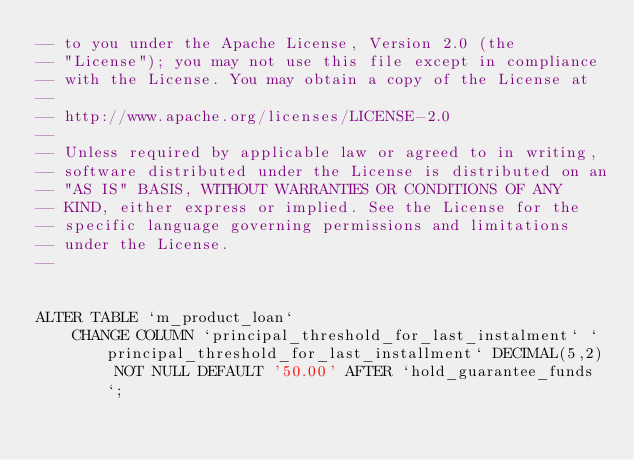<code> <loc_0><loc_0><loc_500><loc_500><_SQL_>-- to you under the Apache License, Version 2.0 (the
-- "License"); you may not use this file except in compliance
-- with the License. You may obtain a copy of the License at
--
-- http://www.apache.org/licenses/LICENSE-2.0
--
-- Unless required by applicable law or agreed to in writing,
-- software distributed under the License is distributed on an
-- "AS IS" BASIS, WITHOUT WARRANTIES OR CONDITIONS OF ANY
-- KIND, either express or implied. See the License for the
-- specific language governing permissions and limitations
-- under the License.
--


ALTER TABLE `m_product_loan`
    CHANGE COLUMN `principal_threshold_for_last_instalment` `principal_threshold_for_last_installment` DECIMAL(5,2) NOT NULL DEFAULT '50.00' AFTER `hold_guarantee_funds`;
</code> 